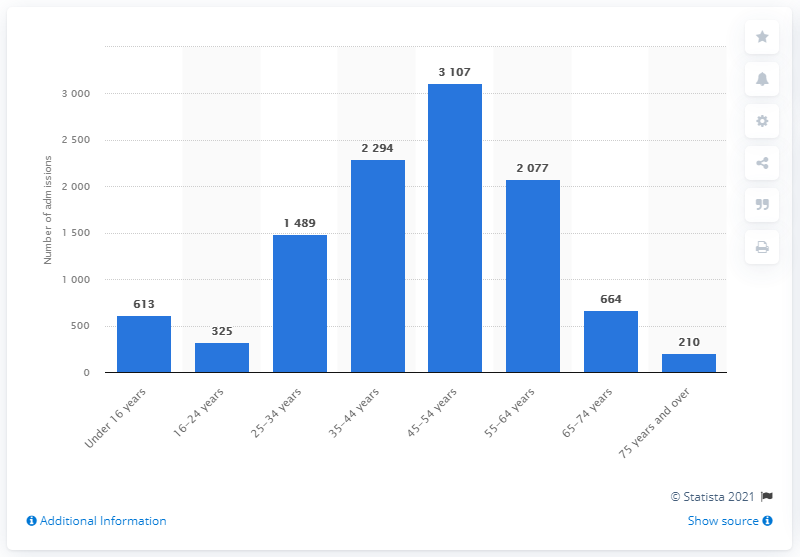Highlight a few significant elements in this photo. There were 7,478 hospital admissions above 2000. The age category with the lowest number of admissions is 75 years and over. 